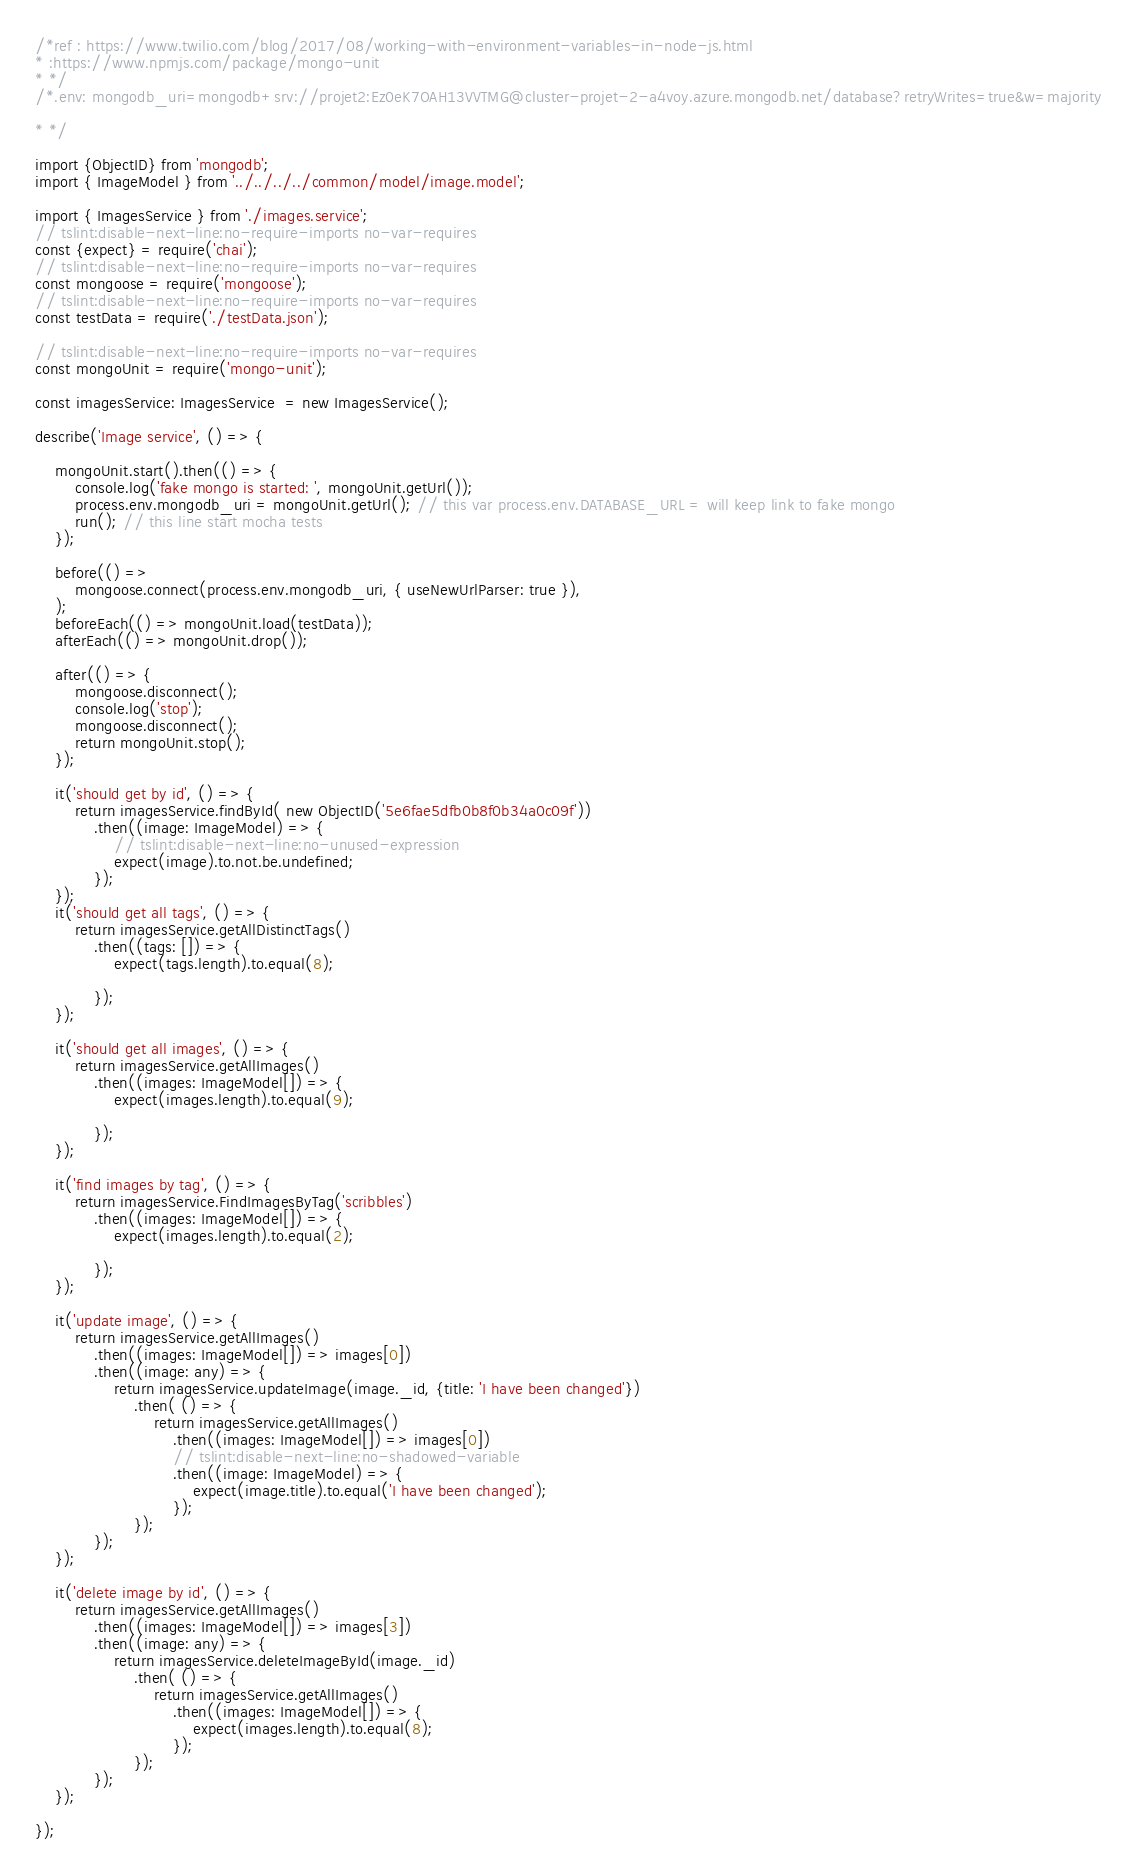Convert code to text. <code><loc_0><loc_0><loc_500><loc_500><_TypeScript_>/*ref : https://www.twilio.com/blog/2017/08/working-with-environment-variables-in-node-js.html
* :https://www.npmjs.com/package/mongo-unit
* */
/*.env: mongodb_uri=mongodb+srv://projet2:Ez0eK7OAH13VVTMG@cluster-projet-2-a4voy.azure.mongodb.net/database?retryWrites=true&w=majority

* */

import {ObjectID} from 'mongodb';
import { ImageModel } from '../../../../common/model/image.model';

import { ImagesService } from './images.service';
// tslint:disable-next-line:no-require-imports no-var-requires
const {expect} = require('chai');
// tslint:disable-next-line:no-require-imports no-var-requires
const mongoose = require('mongoose');
// tslint:disable-next-line:no-require-imports no-var-requires
const testData = require('./testData.json');

// tslint:disable-next-line:no-require-imports no-var-requires
const mongoUnit = require('mongo-unit');

const imagesService: ImagesService  = new ImagesService();

describe('Image service', () => {

    mongoUnit.start().then(() => {
        console.log('fake mongo is started: ', mongoUnit.getUrl());
        process.env.mongodb_uri = mongoUnit.getUrl(); // this var process.env.DATABASE_URL = will keep link to fake mongo
        run(); // this line start mocha tests
    });

    before(() =>
        mongoose.connect(process.env.mongodb_uri, { useNewUrlParser: true }),
    );
    beforeEach(() => mongoUnit.load(testData));
    afterEach(() => mongoUnit.drop());

    after(() => {
        mongoose.disconnect();
        console.log('stop');
        mongoose.disconnect();
        return mongoUnit.stop();
    });

    it('should get by id', () => {
        return imagesService.findById( new ObjectID('5e6fae5dfb0b8f0b34a0c09f'))
            .then((image: ImageModel) => {
                // tslint:disable-next-line:no-unused-expression
                expect(image).to.not.be.undefined;
            });
    });
    it('should get all tags', () => {
        return imagesService.getAllDistinctTags()
            .then((tags: []) => {
                expect(tags.length).to.equal(8);

            });
    });

    it('should get all images', () => {
        return imagesService.getAllImages()
            .then((images: ImageModel[]) => {
                expect(images.length).to.equal(9);

            });
    });

    it('find images by tag', () => {
        return imagesService.FindImagesByTag('scribbles')
            .then((images: ImageModel[]) => {
                expect(images.length).to.equal(2);

            });
    });

    it('update image', () => {
        return imagesService.getAllImages()
            .then((images: ImageModel[]) => images[0])
            .then((image: any) => {
                return imagesService.updateImage(image._id, {title: 'I have been changed'})
                    .then( () => {
                        return imagesService.getAllImages()
                            .then((images: ImageModel[]) => images[0])
                            // tslint:disable-next-line:no-shadowed-variable
                            .then((image: ImageModel) => {
                                expect(image.title).to.equal('I have been changed');
                            });
                    });
            });
    });

    it('delete image by id', () => {
        return imagesService.getAllImages()
            .then((images: ImageModel[]) => images[3])
            .then((image: any) => {
                return imagesService.deleteImageById(image._id)
                    .then( () => {
                        return imagesService.getAllImages()
                            .then((images: ImageModel[]) => {
                                expect(images.length).to.equal(8);
                            });
                    });
            });
    });

});
</code> 